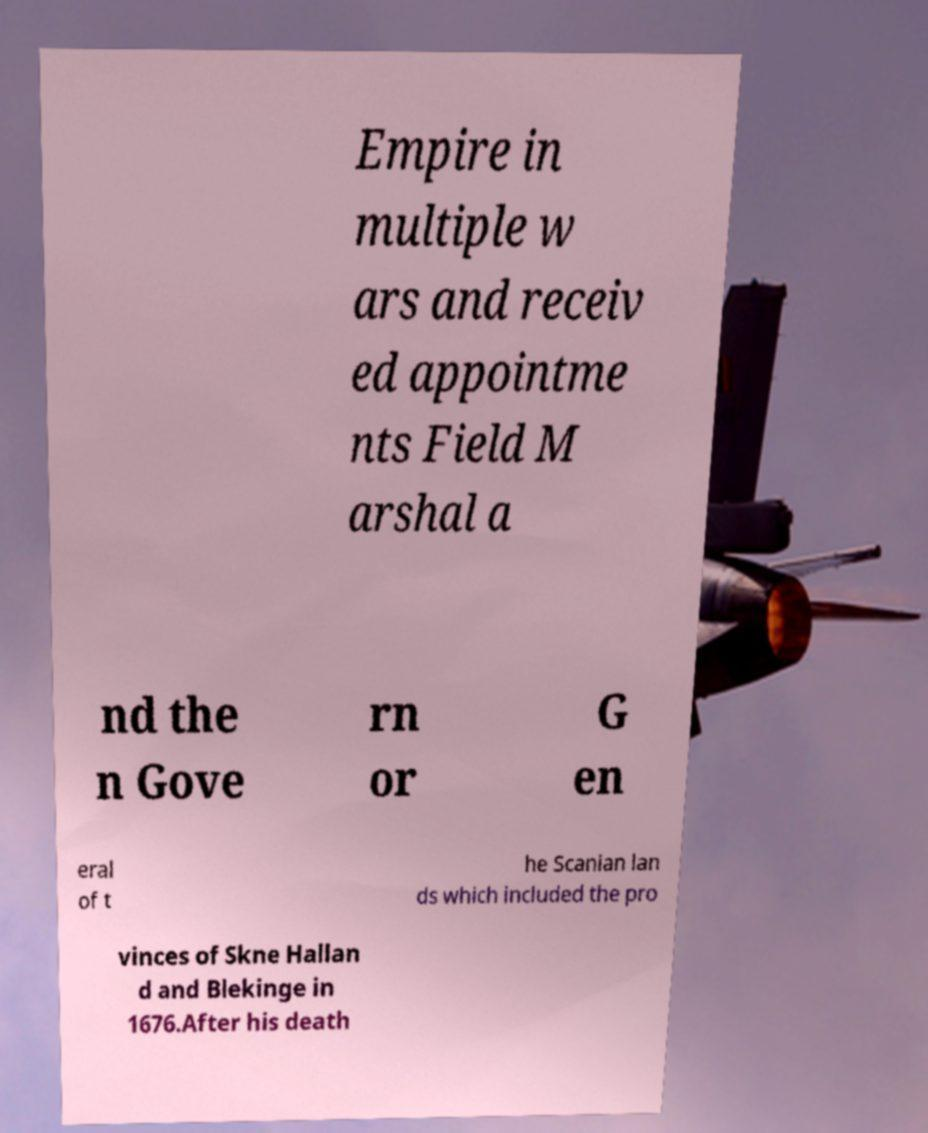What messages or text are displayed in this image? I need them in a readable, typed format. Empire in multiple w ars and receiv ed appointme nts Field M arshal a nd the n Gove rn or G en eral of t he Scanian lan ds which included the pro vinces of Skne Hallan d and Blekinge in 1676.After his death 